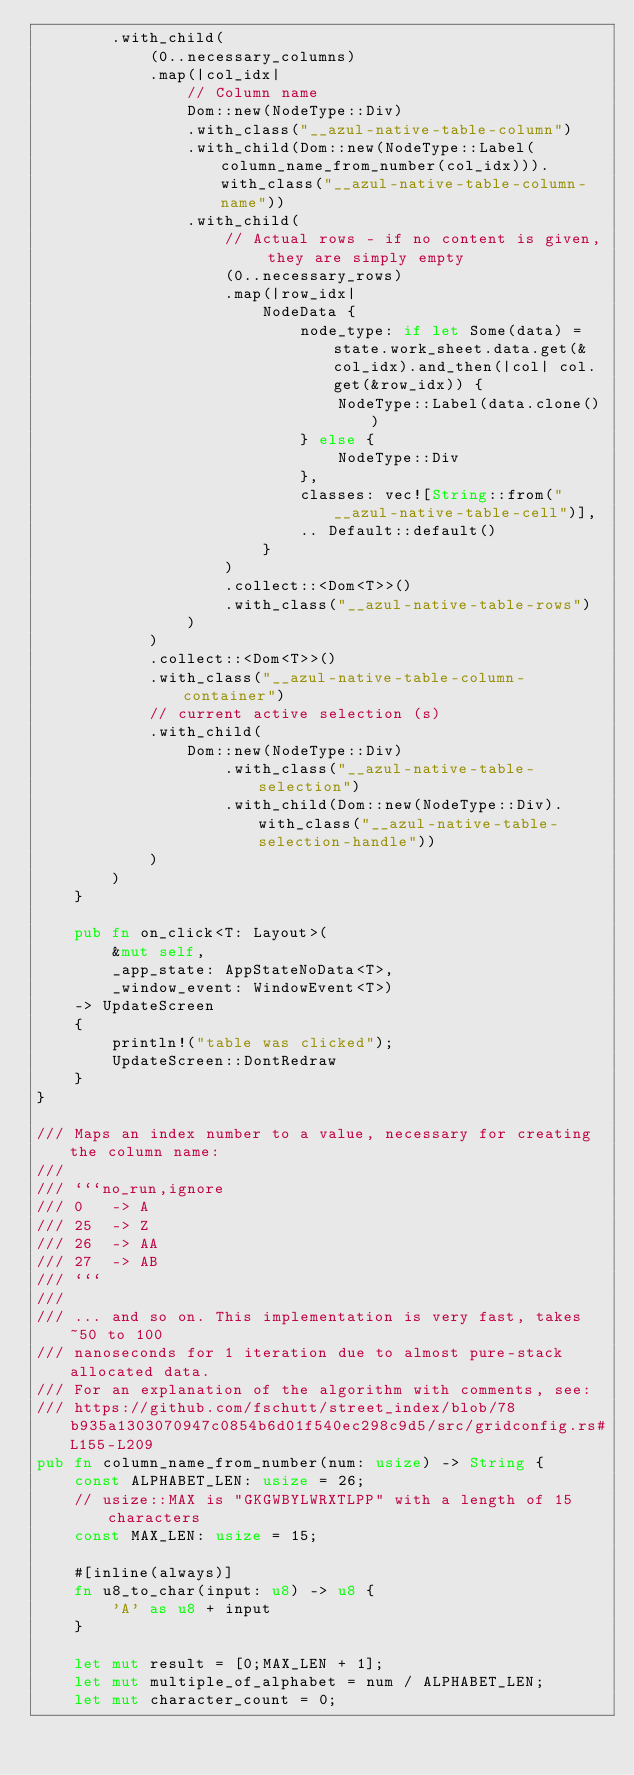Convert code to text. <code><loc_0><loc_0><loc_500><loc_500><_Rust_>        .with_child(
            (0..necessary_columns)
            .map(|col_idx|
                // Column name
                Dom::new(NodeType::Div)
                .with_class("__azul-native-table-column")
                .with_child(Dom::new(NodeType::Label(column_name_from_number(col_idx))).with_class("__azul-native-table-column-name"))
                .with_child(
                    // Actual rows - if no content is given, they are simply empty
                    (0..necessary_rows)
                    .map(|row_idx|
                        NodeData {
                            node_type: if let Some(data) = state.work_sheet.data.get(&col_idx).and_then(|col| col.get(&row_idx)) {
                                NodeType::Label(data.clone())
                            } else {
                                NodeType::Div
                            },
                            classes: vec![String::from("__azul-native-table-cell")],
                            .. Default::default()
                        }
                    )
                    .collect::<Dom<T>>()
                    .with_class("__azul-native-table-rows")
                )
            )
            .collect::<Dom<T>>()
            .with_class("__azul-native-table-column-container")
            // current active selection (s)
            .with_child(
                Dom::new(NodeType::Div)
                    .with_class("__azul-native-table-selection")
                    .with_child(Dom::new(NodeType::Div).with_class("__azul-native-table-selection-handle"))
            )
        )
    }

    pub fn on_click<T: Layout>(
        &mut self,
        _app_state: AppStateNoData<T>,
        _window_event: WindowEvent<T>)
    -> UpdateScreen
    {
        println!("table was clicked");
        UpdateScreen::DontRedraw
    }
}

/// Maps an index number to a value, necessary for creating the column name:
///
/// ```no_run,ignore
/// 0   -> A
/// 25  -> Z
/// 26  -> AA
/// 27  -> AB
/// ```
///
/// ... and so on. This implementation is very fast, takes ~50 to 100
/// nanoseconds for 1 iteration due to almost pure-stack allocated data.
/// For an explanation of the algorithm with comments, see:
/// https://github.com/fschutt/street_index/blob/78b935a1303070947c0854b6d01f540ec298c9d5/src/gridconfig.rs#L155-L209
pub fn column_name_from_number(num: usize) -> String {
    const ALPHABET_LEN: usize = 26;
    // usize::MAX is "GKGWBYLWRXTLPP" with a length of 15 characters
    const MAX_LEN: usize = 15;

    #[inline(always)]
    fn u8_to_char(input: u8) -> u8 {
        'A' as u8 + input
    }

    let mut result = [0;MAX_LEN + 1];
    let mut multiple_of_alphabet = num / ALPHABET_LEN;
    let mut character_count = 0;
</code> 